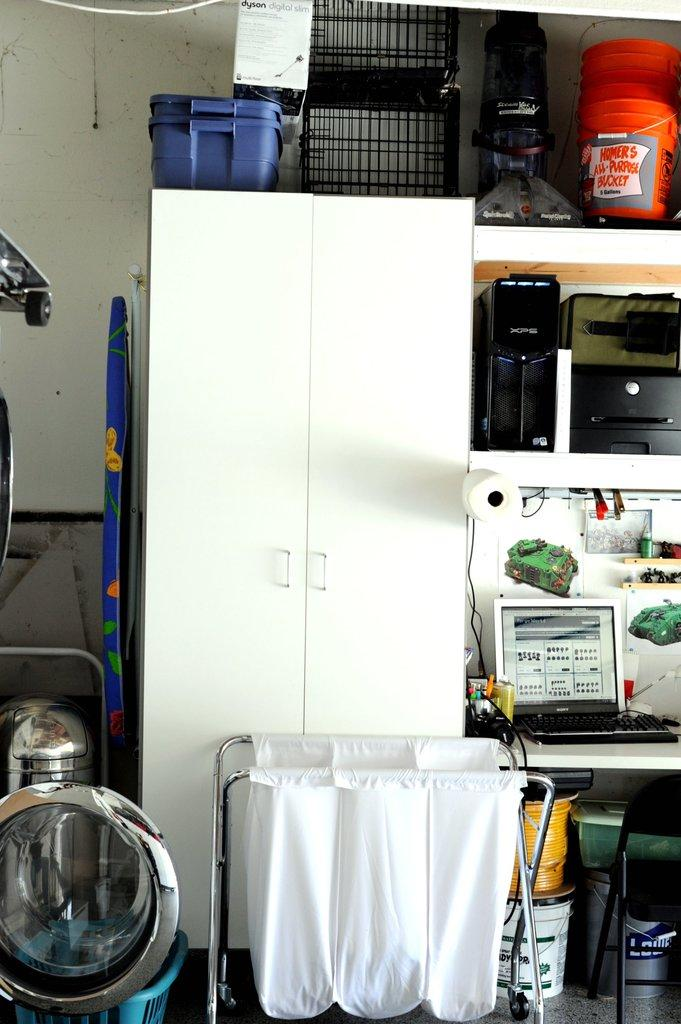<image>
Give a short and clear explanation of the subsequent image. a cluttered storage area with orange buckets from Homer's 